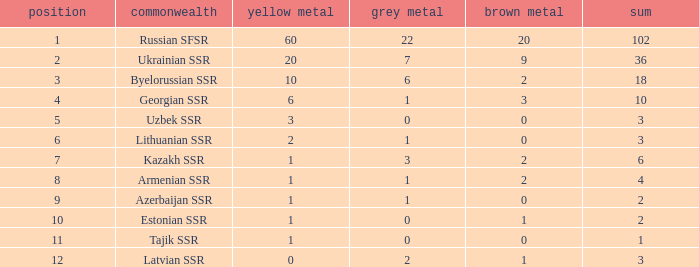What is the highest number of bronzes for teams ranked number 7 with more than 0 silver? 2.0. 